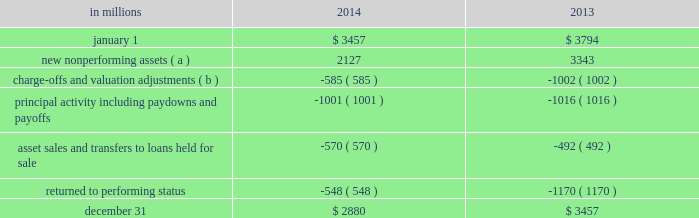Table 32 : change in nonperforming assets .
( a ) new nonperforming assets in the 2013 period include $ 560 million of loans added in the first quarter of 2013 due to the alignment with interagency supervisory guidance on practices for loans and lines of credit related to consumer lending .
( b ) charge-offs and valuation adjustments in the 2013 period include $ 134 million of charge-offs due to the alignment with interagency supervisory guidance discussed in footnote ( a ) above .
The table above presents nonperforming asset activity during 2014 and 2013 , respectively .
Nonperforming assets decreased $ 577 million from $ 3.5 billion at december 31 , 2013 to $ 2.9 billion at december 31 , 2014 , as a result of improvements in both consumer and commercial lending .
Consumer lending nonperforming loans decreased $ 224 million , commercial real estate nonperforming loans declined $ 184 million and commercial nonperforming loans decreased $ 167 million .
As of december 31 , 2014 , approximately 90% ( 90 % ) of total nonperforming loans were secured by collateral which lessens reserve requirements and is expected to reduce credit losses in the event of default .
As of december 31 , 2014 , commercial lending nonperforming loans were carried at approximately 65% ( 65 % ) of their unpaid principal balance , due to charge-offs recorded to date , before consideration of the alll .
See note 3 asset quality in the notes to consolidated financial statements in item 8 of this report for additional information on these loans .
Purchased impaired loans are considered performing , even if contractually past due ( or if we do not expect to receive payment in full based on the original contractual terms ) , as we accrete interest income over the expected life of the loans .
The accretable yield represents the excess of the expected cash flows on the loans at the measurement date over the carrying value .
Generally decreases , other than interest rate decreases for variable rate notes , in the net present value of expected cash flows of individual commercial or pooled purchased impaired loans would result in an impairment charge to the provision for credit losses in the period in which the change is deemed probable .
Generally increases in the net present value of expected cash flows of purchased impaired loans would first result in a recovery of previously recorded allowance for loan losses , to the extent applicable , and then an increase to accretable yield for the remaining life of the purchased impaired loans .
Total nonperforming loans and assets in the tables above are significantly lower than they would have been due to this accounting treatment for purchased impaired loans .
This treatment also results in a lower ratio of nonperforming loans to total loans and a higher ratio of alll to nonperforming loans .
See note 4 purchased loans in the notes to consolidated financial statements in item 8 of this report for additional information on these loans .
Loan delinquencies we regularly monitor the level of loan delinquencies and believe these levels may be a key indicator of loan portfolio asset quality .
Measurement of delinquency status is based on the contractual terms of each loan .
Loans that are 30 days or more past due in terms of payment are considered delinquent .
Loan delinquencies exclude loans held for sale and purchased impaired loans , but include government insured or guaranteed loans and loans accounted for under the fair value option .
Total early stage loan delinquencies ( accruing loans past due 30 to 89 days ) decreased from $ 1.0 billion at december 31 , 2013 to $ 0.8 billion at december 31 , 2014 .
The reduction in both consumer and commercial lending early stage delinquencies resulted from improved credit quality .
See note 1 accounting policies in the notes to consolidated financial statements of this report for additional information regarding our nonperforming loan and nonaccrual policies .
Accruing loans past due 90 days or more are referred to as late stage delinquencies .
These loans are not included in nonperforming loans and continue to accrue interest because they are well secured by collateral , and/or are in the process of collection , are managed in homogenous portfolios with specified charge-off timeframes adhering to regulatory guidelines , or are certain government insured or guaranteed loans .
These loans decreased $ .4 billion , or 26% ( 26 % ) , from $ 1.5 billion at december 31 , 2013 to $ 1.1 billion at december 31 , 2014 , mainly due to a decline in government insured residential real estate loans of $ .3 billion , the majority of which we took possession of and conveyed the real estate , or are in the process of conveyance and claim resolution .
The following tables display the delinquency status of our loans at december 31 , 2014 and december 31 , 2013 .
Additional information regarding accruing loans past due is included in note 3 asset quality in the notes to consolidated financial statements of this report .
74 the pnc financial services group , inc .
2013 form 10-k .
What is the percentage decrease of nonperforming assets from dec 31 2013 to dec 31 2014? 
Computations: (((3457 - 2880) / 3457) * 100)
Answer: 16.69077. 